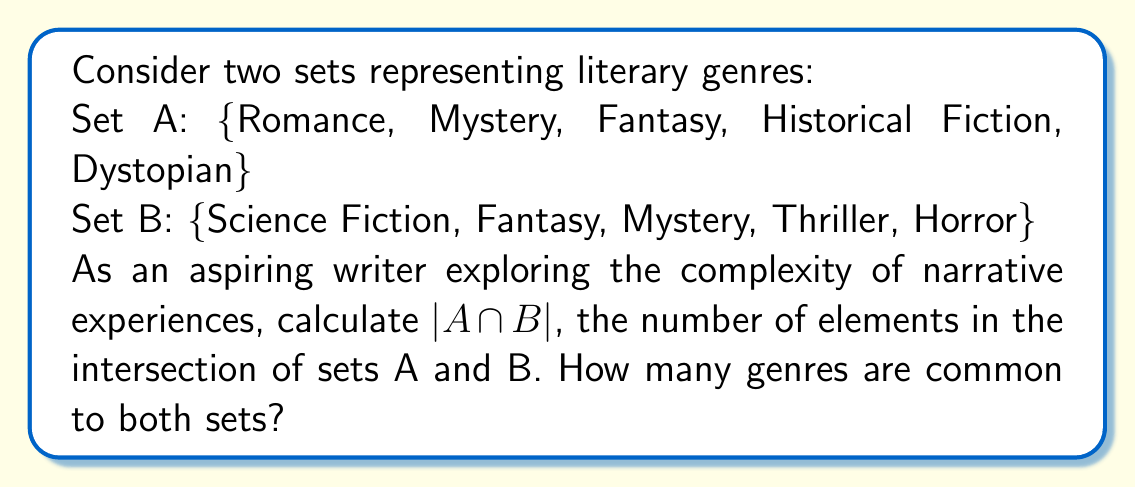Can you answer this question? To solve this problem, we need to follow these steps:

1. Identify the elements in set A:
   A = {Romance, Mystery, Fantasy, Historical Fiction, Dystopian}

2. Identify the elements in set B:
   B = {Science Fiction, Fantasy, Mystery, Thriller, Horror}

3. Find the intersection of sets A and B:
   A ∩ B is the set of elements that are present in both A and B.

4. List the common elements:
   - Fantasy is in both sets
   - Mystery is in both sets

5. Count the number of elements in the intersection:
   $|A \cap B| = 2$

This result shows that there are two genres common to both sets, which could be particularly interesting for a writer exploring the complexities of narrative across different genre boundaries. These shared genres (Fantasy and Mystery) might offer rich opportunities for blending elements and creating more immersive, complex narratives that appeal to readers of both genre sets.
Answer: $|A \cap B| = 2$ 